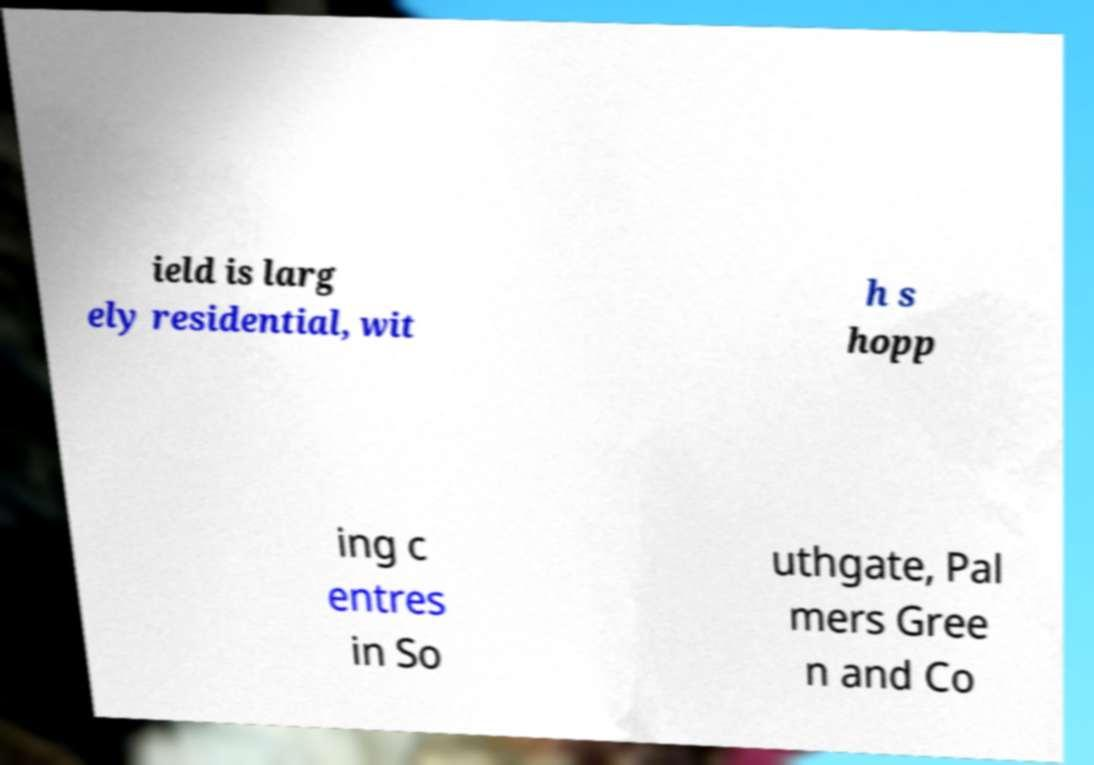Can you accurately transcribe the text from the provided image for me? ield is larg ely residential, wit h s hopp ing c entres in So uthgate, Pal mers Gree n and Co 